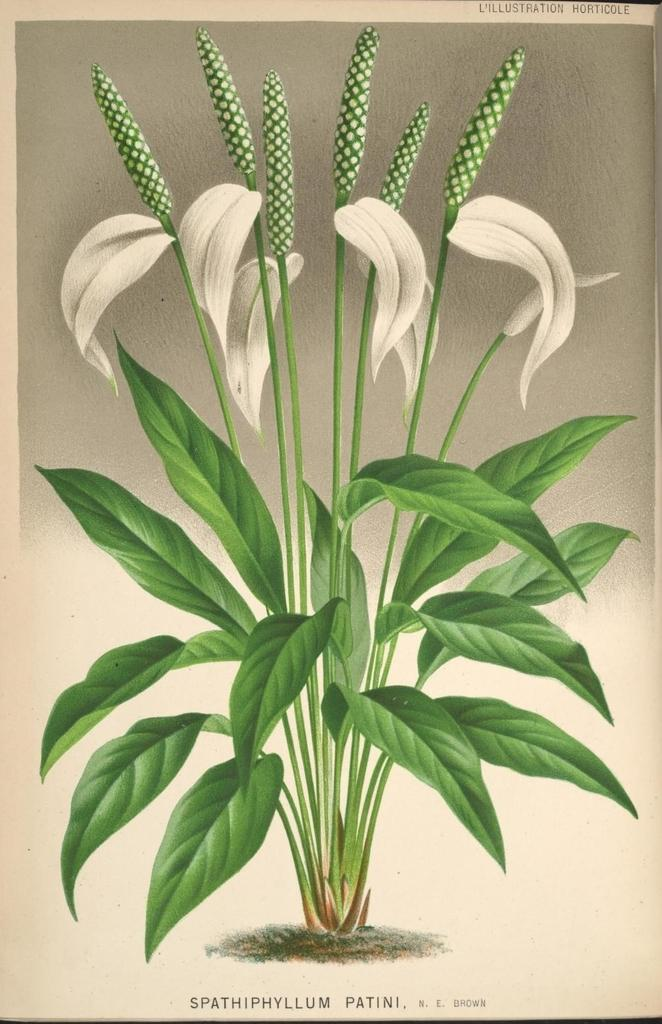What is featured on the poster in the image? There is a poster in the image that depicts a plant. Can you describe the plant on the poster? The plant on the poster has flowers and buds. What type of disease can be seen affecting the plant in the image? There is no indication of any disease affecting the plant in the image; the plant appears healthy with flowers and buds. How does the plant run away from the poster in the image? Plants do not have the ability to run, and the plant in the image is a static image on a poster. 